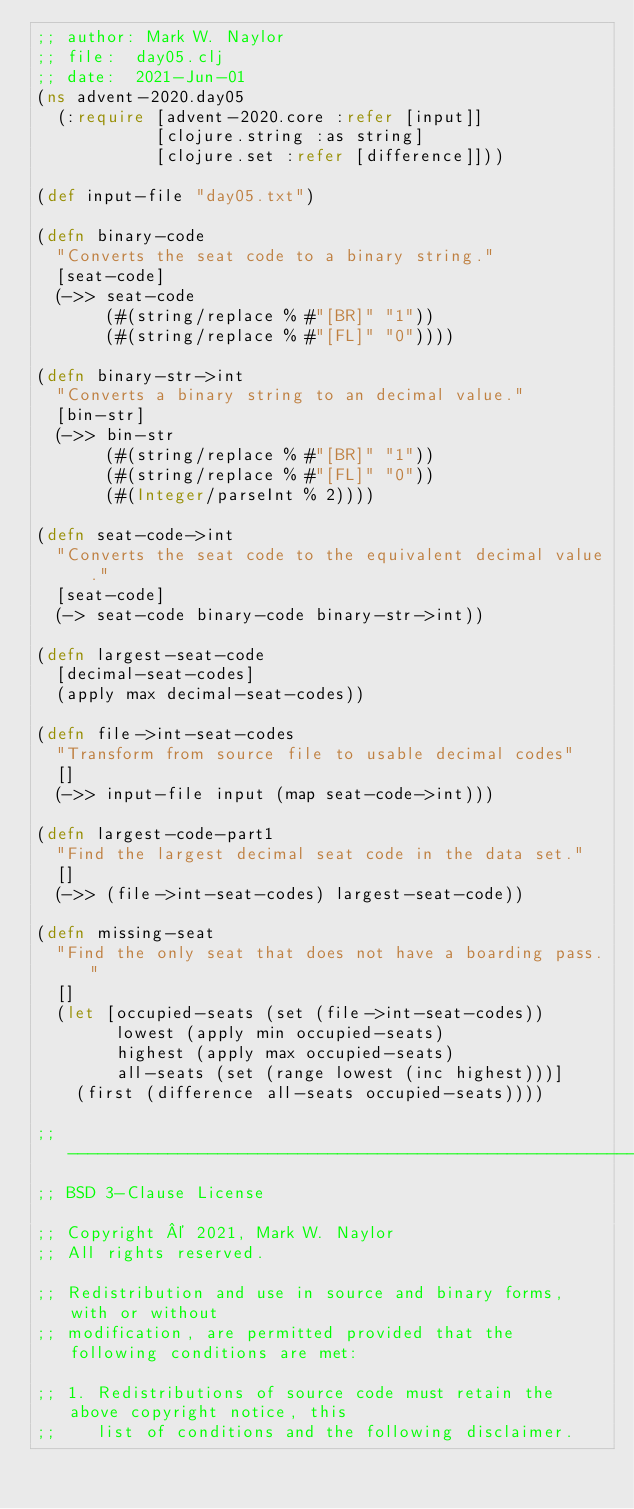<code> <loc_0><loc_0><loc_500><loc_500><_Clojure_>;; author: Mark W. Naylor
;; file:  day05.clj
;; date:  2021-Jun-01
(ns advent-2020.day05
  (:require [advent-2020.core :refer [input]]
            [clojure.string :as string]
            [clojure.set :refer [difference]]))

(def input-file "day05.txt")

(defn binary-code
  "Converts the seat code to a binary string."
  [seat-code]
  (->> seat-code
       (#(string/replace % #"[BR]" "1"))
       (#(string/replace % #"[FL]" "0"))))

(defn binary-str->int
  "Converts a binary string to an decimal value."
  [bin-str]
  (->> bin-str
       (#(string/replace % #"[BR]" "1"))
       (#(string/replace % #"[FL]" "0"))
       (#(Integer/parseInt % 2))))

(defn seat-code->int
  "Converts the seat code to the equivalent decimal value."
  [seat-code]
  (-> seat-code binary-code binary-str->int))

(defn largest-seat-code
  [decimal-seat-codes]
  (apply max decimal-seat-codes))

(defn file->int-seat-codes
  "Transform from source file to usable decimal codes"
  []
  (->> input-file input (map seat-code->int)))

(defn largest-code-part1
  "Find the largest decimal seat code in the data set."
  []
  (->> (file->int-seat-codes) largest-seat-code))

(defn missing-seat
  "Find the only seat that does not have a boarding pass."
  []
  (let [occupied-seats (set (file->int-seat-codes))
        lowest (apply min occupied-seats)
        highest (apply max occupied-seats)
        all-seats (set (range lowest (inc highest)))]
    (first (difference all-seats occupied-seats))))

;; ------------------------------------------------------------------------------
;; BSD 3-Clause License

;; Copyright © 2021, Mark W. Naylor
;; All rights reserved.

;; Redistribution and use in source and binary forms, with or without
;; modification, are permitted provided that the following conditions are met:

;; 1. Redistributions of source code must retain the above copyright notice, this
;;    list of conditions and the following disclaimer.
</code> 